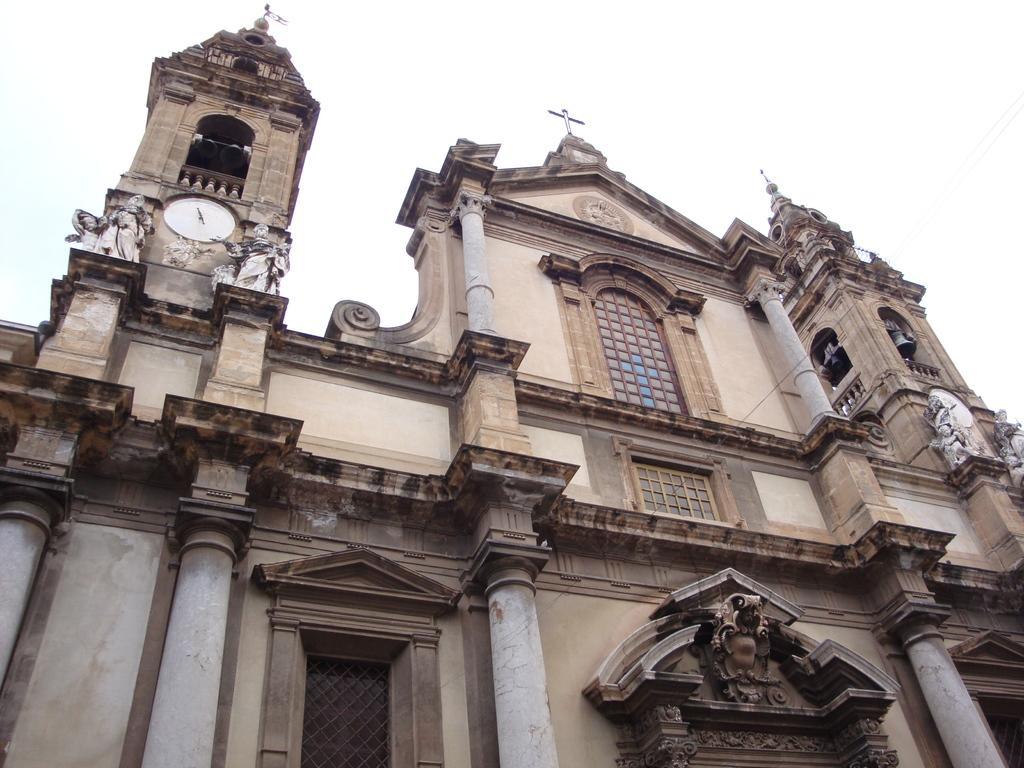Could you give a brief overview of what you see in this image? In this image I can see the building. There are some statues can be seen to the building. I can also see the clock to the building. In the back I can see the white sky. 